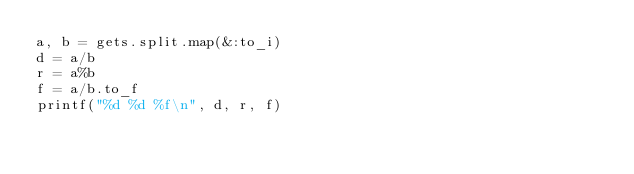Convert code to text. <code><loc_0><loc_0><loc_500><loc_500><_Ruby_>a, b = gets.split.map(&:to_i)
d = a/b
r = a%b
f = a/b.to_f
printf("%d %d %f\n", d, r, f)</code> 